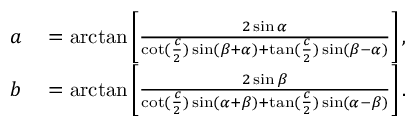Convert formula to latex. <formula><loc_0><loc_0><loc_500><loc_500>\begin{array} { r l } { a } & = \arctan \left [ { \frac { 2 \sin \alpha } { \cot ( { \frac { c } { 2 } } ) \sin ( \beta + \alpha ) + \tan ( { \frac { c } { 2 } } ) \sin ( \beta - \alpha ) } } \right ] , } \\ { b } & = \arctan \left [ { \frac { 2 \sin \beta } { \cot ( { \frac { c } { 2 } } ) \sin ( \alpha + \beta ) + \tan ( { \frac { c } { 2 } } ) \sin ( \alpha - \beta ) } } \right ] . } \end{array}</formula> 